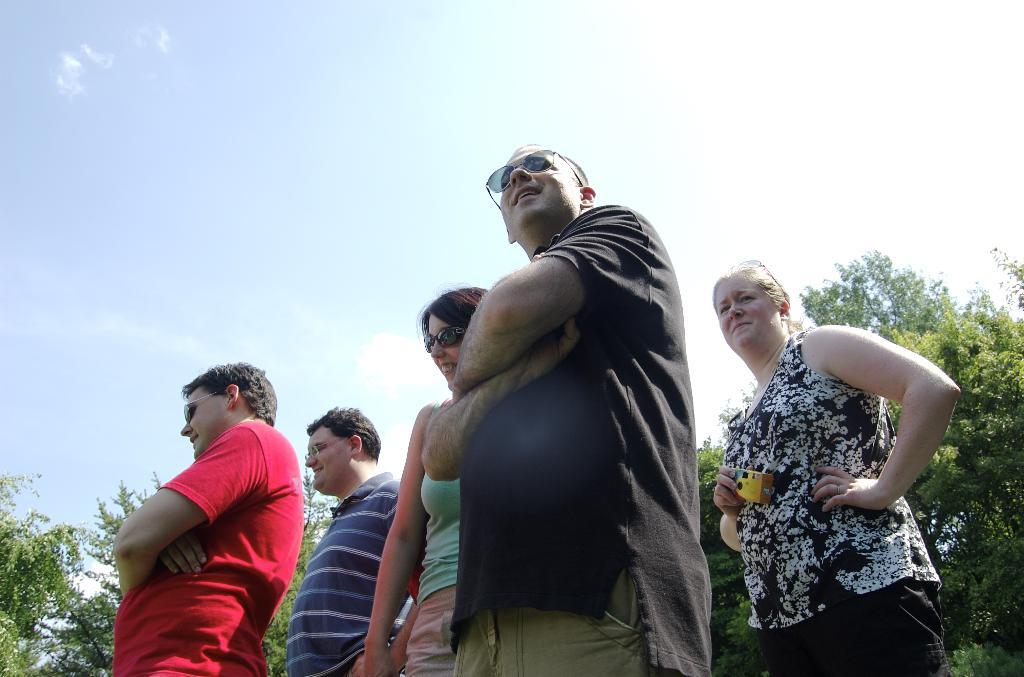What is happening in the image involving a group of people? There is a group of people standing in the image. Can you describe the lady's action in the image? A lady is holding an object at the right side of the image. What type of natural environment is depicted in the image? There are many trees in the image, suggesting a forest or park setting. What can be seen above the people and trees in the image? The sky is visible in the image. Where is the drain located in the image? There is no drain present in the image. What shape is the net in the image? There is no net present in the image. 